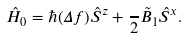<formula> <loc_0><loc_0><loc_500><loc_500>\hat { H } _ { 0 } = \hbar { ( } \Delta f ) \hat { S } ^ { z } + \frac { } { 2 } \tilde { B } _ { 1 } \hat { S } ^ { x } .</formula> 